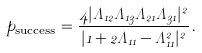<formula> <loc_0><loc_0><loc_500><loc_500>p _ { \text {success} } = \frac { 4 | \Lambda _ { 1 2 } \Lambda _ { 1 3 } \Lambda _ { 2 1 } \Lambda _ { 3 1 } | ^ { 2 } } { | 1 + 2 \Lambda _ { 1 1 } - \Lambda _ { 1 1 } ^ { 2 } | ^ { 2 } } \, .</formula> 